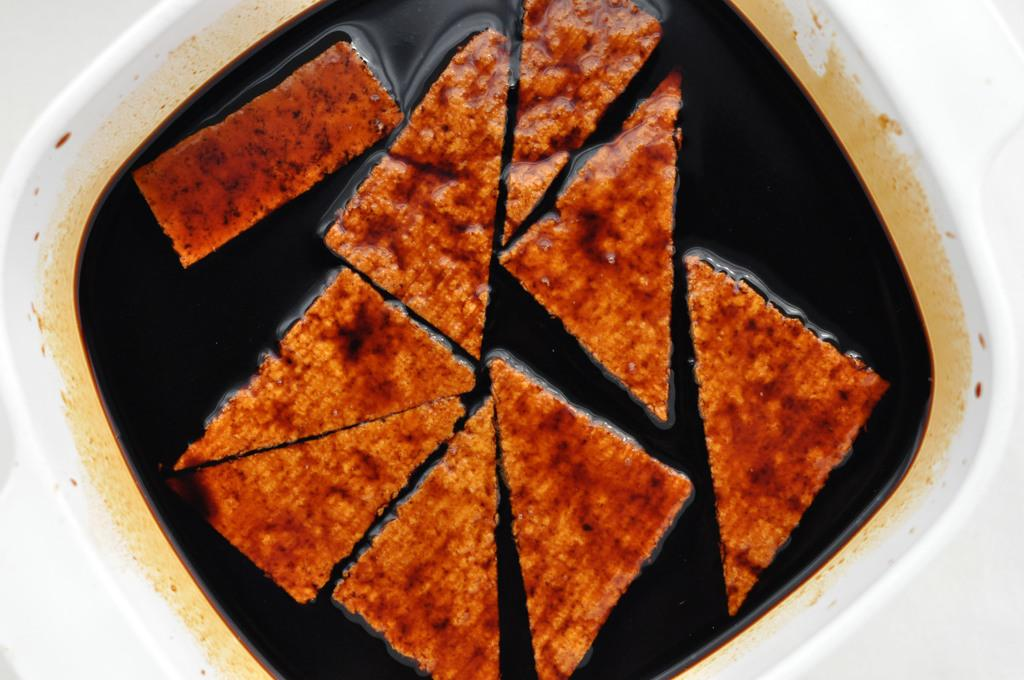What type of food is in the image? The image contains food, but the specific type is not mentioned. What else is present in the bowl with the food? There is liquid in the bowl with the food. Can you describe the container holding the food and liquid? Both the food and liquid are in a bowl. What type of tent is visible in the image? There is no tent present in the image. How does the son contribute to the preparation of the food in the image? There is no mention of a son or cooking in the image, so it is not possible to answer this question. 